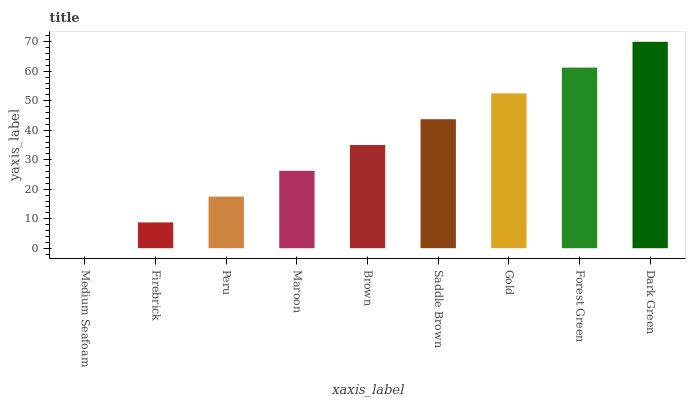Is Medium Seafoam the minimum?
Answer yes or no. Yes. Is Dark Green the maximum?
Answer yes or no. Yes. Is Firebrick the minimum?
Answer yes or no. No. Is Firebrick the maximum?
Answer yes or no. No. Is Firebrick greater than Medium Seafoam?
Answer yes or no. Yes. Is Medium Seafoam less than Firebrick?
Answer yes or no. Yes. Is Medium Seafoam greater than Firebrick?
Answer yes or no. No. Is Firebrick less than Medium Seafoam?
Answer yes or no. No. Is Brown the high median?
Answer yes or no. Yes. Is Brown the low median?
Answer yes or no. Yes. Is Peru the high median?
Answer yes or no. No. Is Maroon the low median?
Answer yes or no. No. 